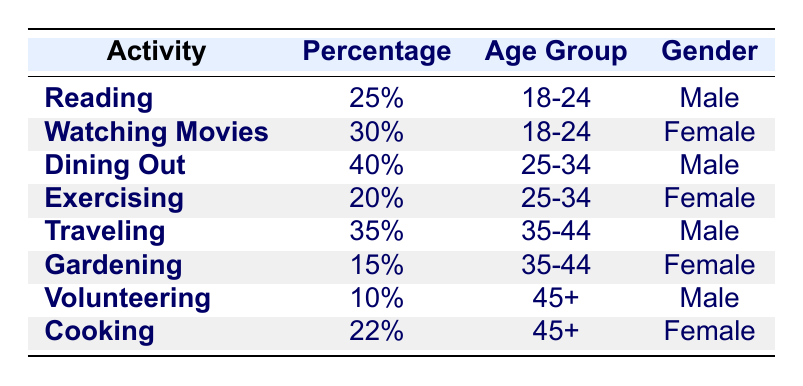What is the most popular leisure activity among males aged 25-34? According to the table, the most popular leisure activity among males aged 25-34 is "Dining Out," which has a percentage of 40%.
Answer: Dining Out What percentage of females aged 35-44 enjoy gardening? The table shows that the percentage of females aged 35-44 who enjoy gardening is 15%.
Answer: 15% Is "Traveling" more popular among males aged 35-44 than "Gardening" is among females aged the same age group? "Traveling" has a percentage of 35% among males aged 35-44, while "Gardening" has 15% among females in the same age group. Since 35% is greater than 15%, the answer is yes.
Answer: Yes What is the average percentage of leisure activities for females across all age groups? The percentages for females are 30% (Watching Movies), 20% (Exercising), 15% (Gardening), and 22% (Cooking). First, we add those percentages: 30 + 20 + 15 + 22 = 87. Then, we divide by the number of data points, which is 4: 87/4 = 21.75.
Answer: 21.75 Is it true that more than 20% of adults aged 45 and older prefer cooking? The table shows that the percentage of females aged 45+ who prefer cooking is 22%, which is indeed more than 20%. Therefore, the statement is true.
Answer: Yes What activity has the lowest percentage among all groups? The table lists "Volunteering" with a percentage of 10%, which is the lowest of all activities listed.
Answer: Volunteering Which age group has the highest percentage for the leisure activity "Watching Movies"? "Watching Movies" has a percentage of 30% and is associated with the age group 18-24, making it the highest percentage for that activity across age groups.
Answer: 18-24 What is the difference in percentage between "Dining Out" for males aged 25-34 and "Cooking" for females aged 45+? "Dining Out" is at 40% for males aged 25-34, and "Cooking" is at 22% for females aged 45+. The difference is 40% - 22% = 18%.
Answer: 18% 